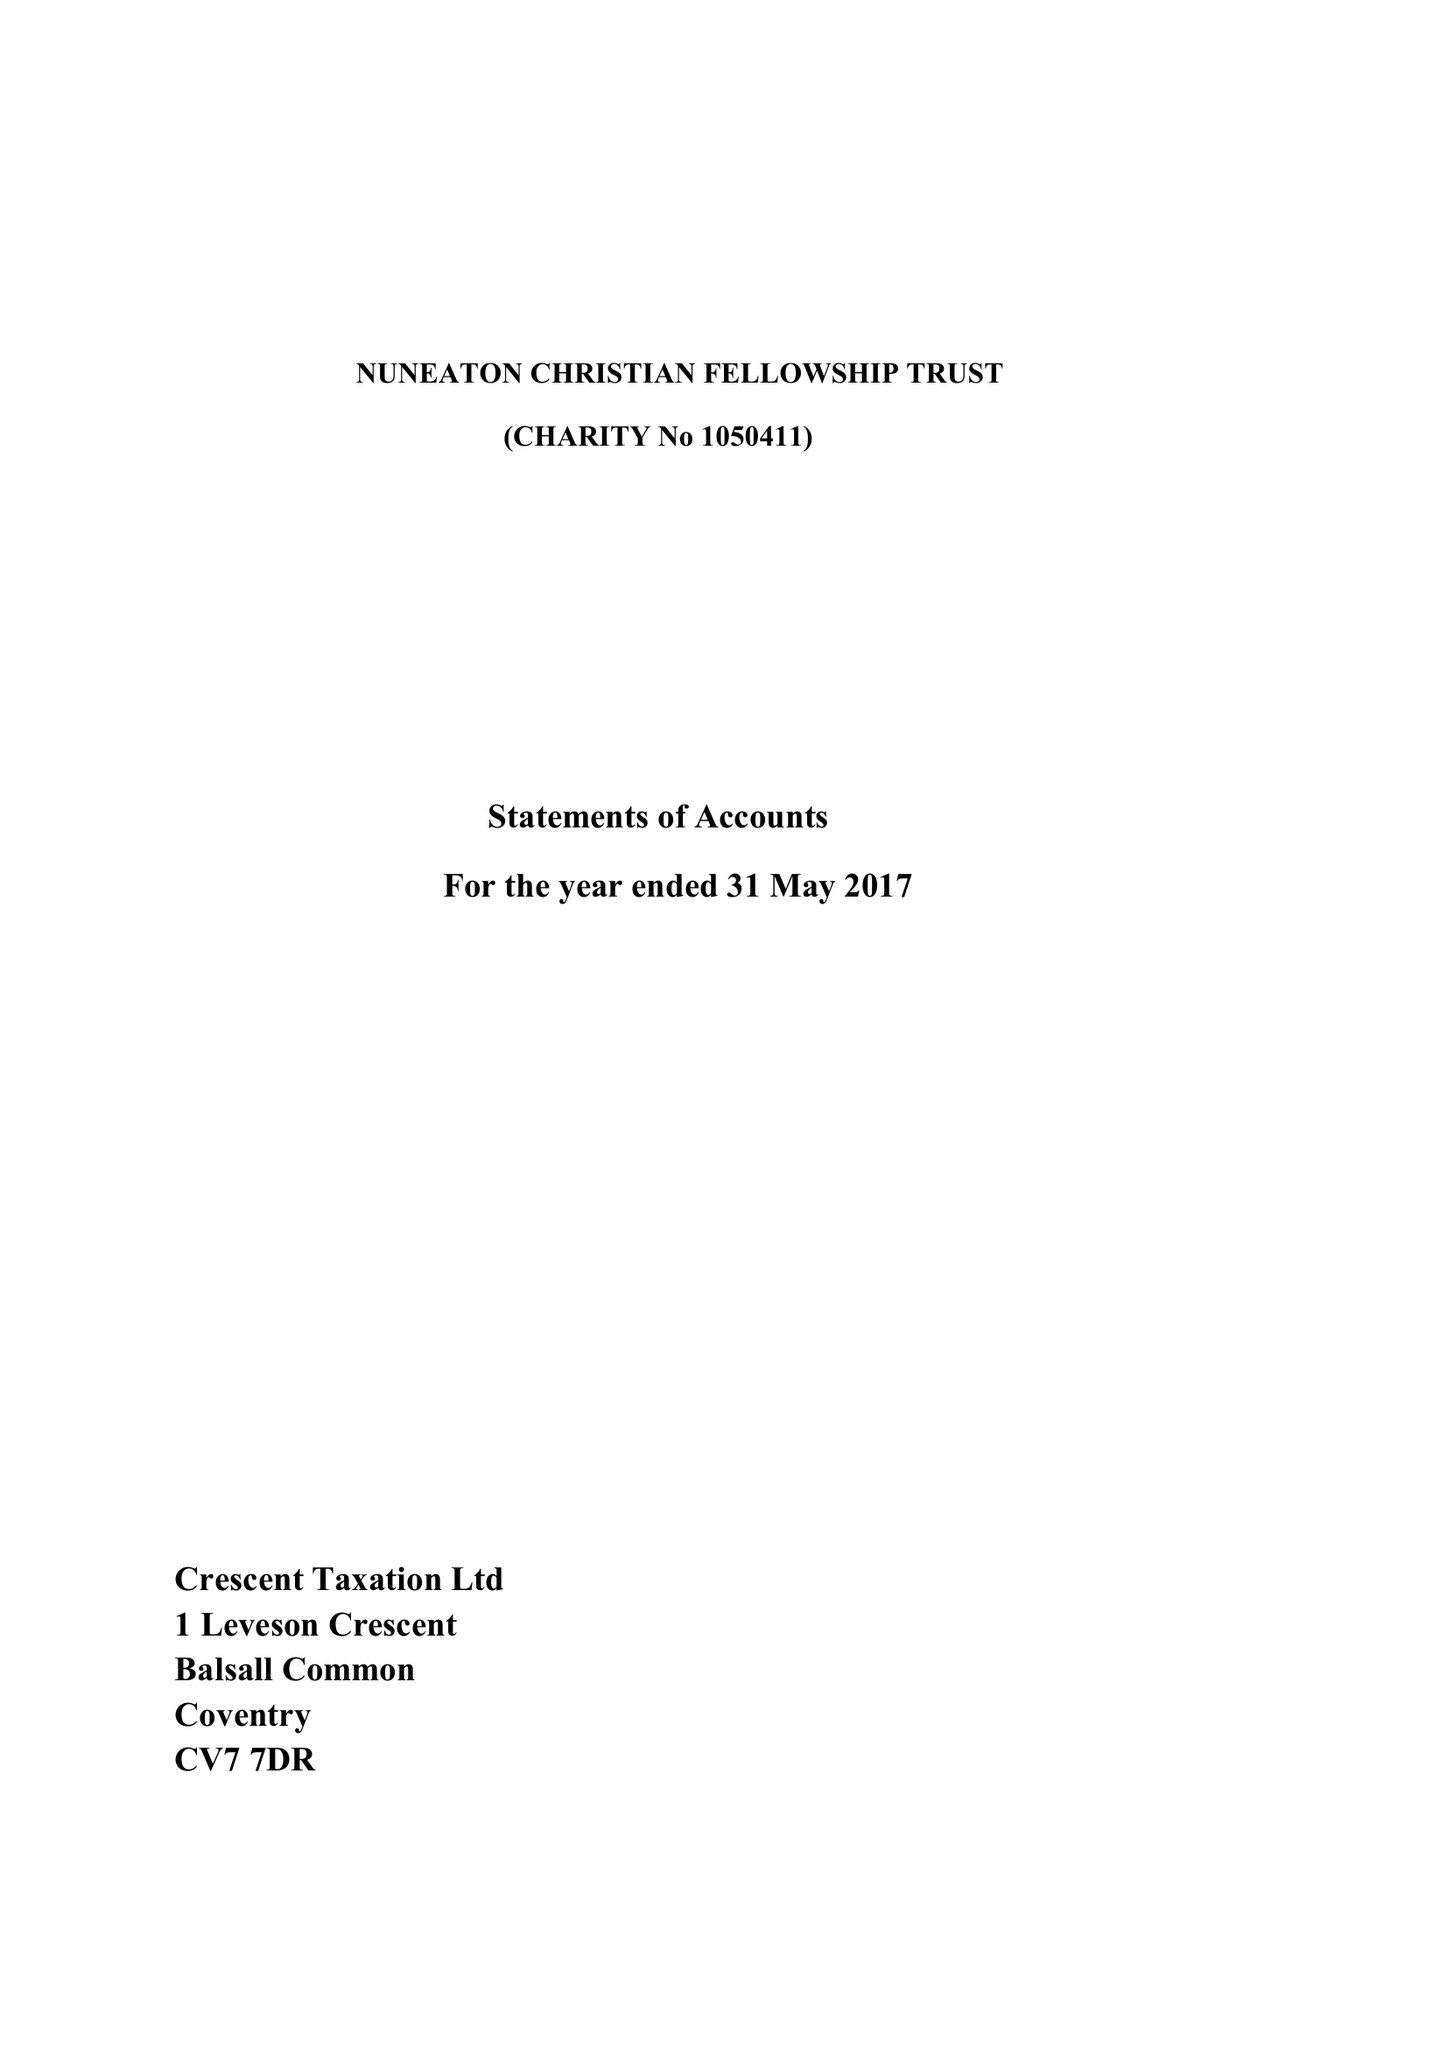What is the value for the address__post_town?
Answer the question using a single word or phrase. NUNEATON 